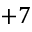Convert formula to latex. <formula><loc_0><loc_0><loc_500><loc_500>+ 7</formula> 